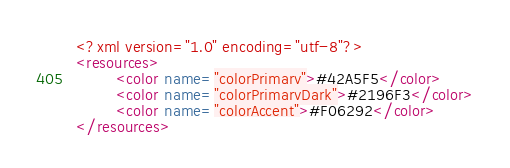<code> <loc_0><loc_0><loc_500><loc_500><_XML_><?xml version="1.0" encoding="utf-8"?>
<resources>
        <color name="colorPrimary">#42A5F5</color>
        <color name="colorPrimaryDark">#2196F3</color>
        <color name="colorAccent">#F06292</color>
</resources>
</code> 